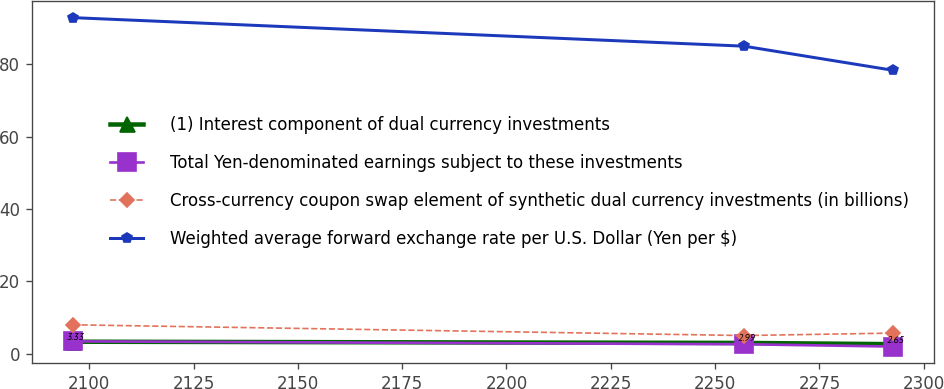Convert chart. <chart><loc_0><loc_0><loc_500><loc_500><line_chart><ecel><fcel>(1) Interest component of dual currency investments<fcel>Total Yen-denominated earnings subject to these investments<fcel>Cross-currency coupon swap element of synthetic dual currency investments (in billions)<fcel>Weighted average forward exchange rate per U.S. Dollar (Yen per $)<nl><fcel>2096.05<fcel>3.33<fcel>3.43<fcel>8<fcel>92.84<nl><fcel>2256.92<fcel>2.99<fcel>2.63<fcel>5.03<fcel>84.96<nl><fcel>2292.65<fcel>2.65<fcel>2<fcel>5.71<fcel>78.29<nl></chart> 